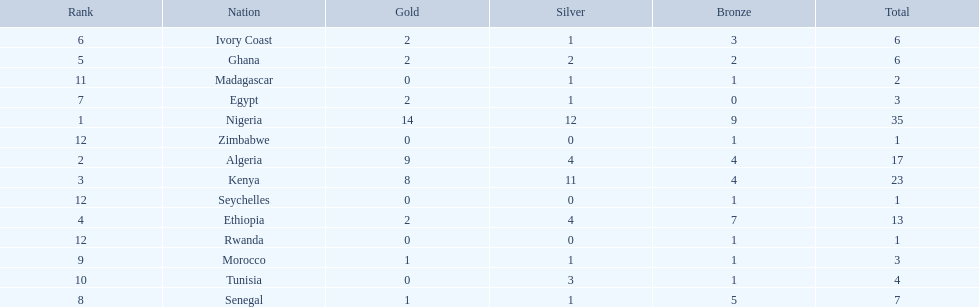What nations competed at the 1989 african championships in athletics? Nigeria, Algeria, Kenya, Ethiopia, Ghana, Ivory Coast, Egypt, Senegal, Morocco, Tunisia, Madagascar, Rwanda, Zimbabwe, Seychelles. What nations earned bronze medals? Nigeria, Algeria, Kenya, Ethiopia, Ghana, Ivory Coast, Senegal, Morocco, Tunisia, Madagascar, Rwanda, Zimbabwe, Seychelles. What nation did not earn a bronze medal? Egypt. 